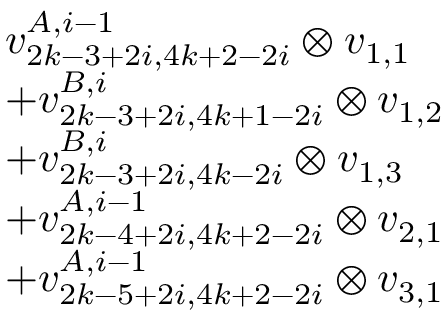Convert formula to latex. <formula><loc_0><loc_0><loc_500><loc_500>\begin{array} { r l } & { v _ { 2 k - 3 + 2 i , 4 k + 2 - 2 i } ^ { A , i - 1 } \otimes v _ { 1 , 1 } } \\ & { + v _ { 2 k - 3 + 2 i , 4 k + 1 - 2 i } ^ { B , i } \otimes v _ { 1 , 2 } } \\ & { + v _ { 2 k - 3 + 2 i , 4 k - 2 i } ^ { B , i } \otimes v _ { 1 , 3 } } \\ & { + v _ { 2 k - 4 + 2 i , 4 k + 2 - 2 i } ^ { A , i - 1 } \otimes v _ { 2 , 1 } } \\ & { + v _ { 2 k - 5 + 2 i , 4 k + 2 - 2 i } ^ { A , i - 1 } \otimes v _ { 3 , 1 } } \end{array}</formula> 